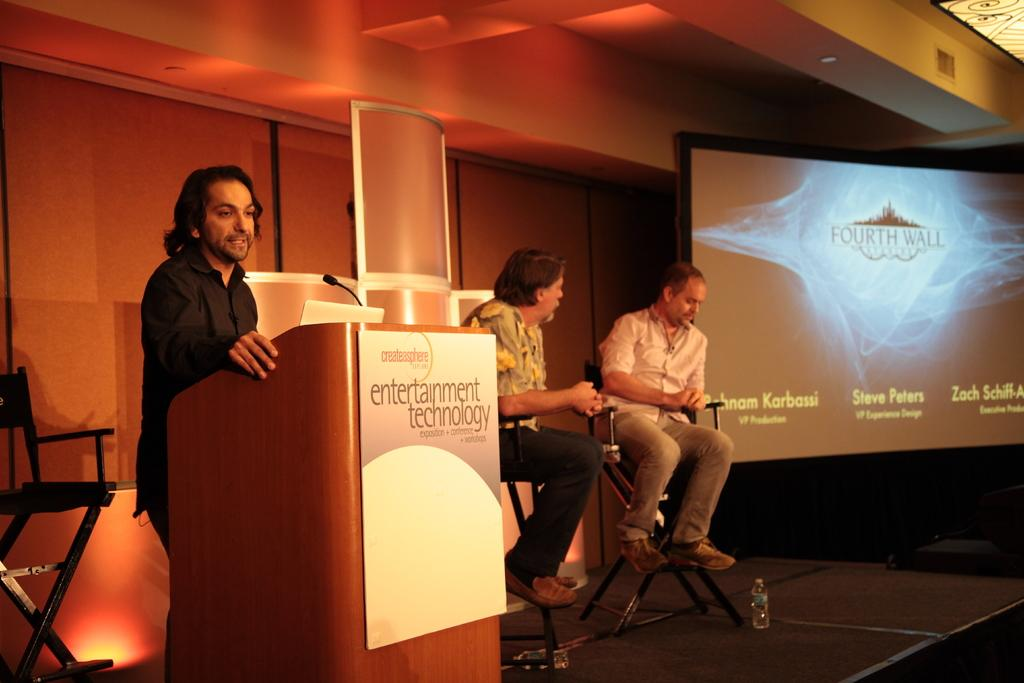<image>
Provide a brief description of the given image. Poster board with a createasphere logo and entertainment technology sign. 